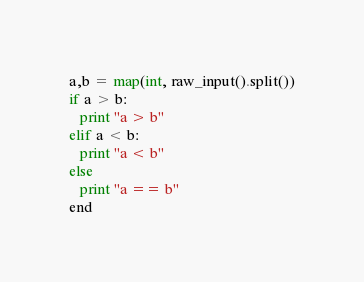<code> <loc_0><loc_0><loc_500><loc_500><_Python_>a,b = map(int, raw_input().split())
if a > b:
   print "a > b"
elif a < b:
   print "a < b"
else
   print "a == b"
end</code> 